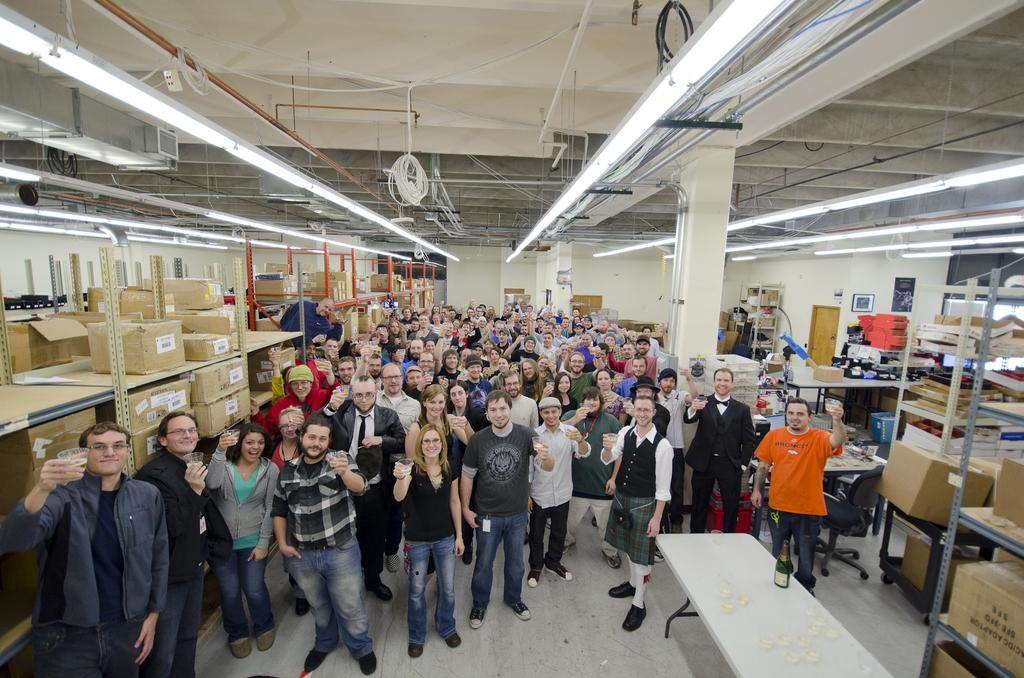What can be seen in the image? There are people standing in the image. What is located on either side of the people? There are racks on either side of the people. What is on the racks? There are boxes on the racks. What is visible at the top of the image? There are lights at the top of the image. Where is the mailbox located in the image? There is no mailbox present in the image. What type of coach is standing among the people in the image? There are no coaches present in the image; only people are visible. 